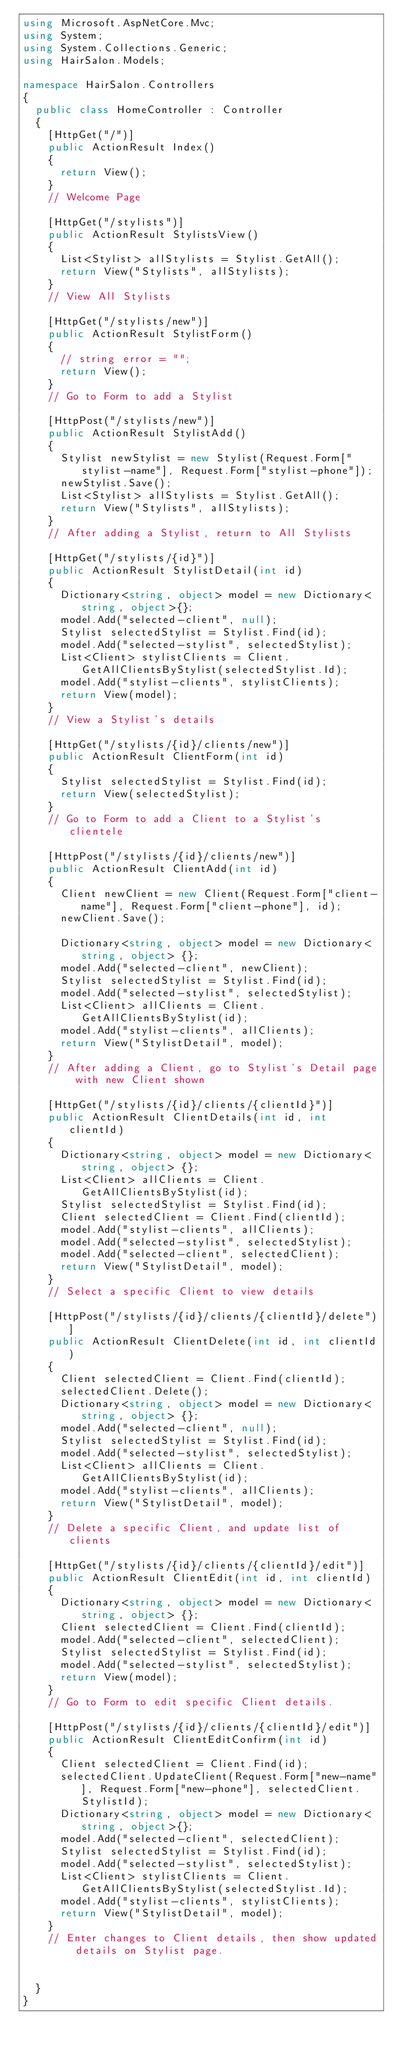Convert code to text. <code><loc_0><loc_0><loc_500><loc_500><_C#_>using Microsoft.AspNetCore.Mvc;
using System;
using System.Collections.Generic;
using HairSalon.Models;

namespace HairSalon.Controllers
{
  public class HomeController : Controller
  {
    [HttpGet("/")]
    public ActionResult Index()
    {
      return View();
    }
    // Welcome Page

    [HttpGet("/stylists")]
    public ActionResult StylistsView()
    {
      List<Stylist> allStylists = Stylist.GetAll();
      return View("Stylists", allStylists);
    }
    // View All Stylists

    [HttpGet("/stylists/new")]
    public ActionResult StylistForm()
    {
      // string error = "";
      return View();
    }
    // Go to Form to add a Stylist

    [HttpPost("/stylists/new")]
    public ActionResult StylistAdd()
    {
      Stylist newStylist = new Stylist(Request.Form["stylist-name"], Request.Form["stylist-phone"]);
      newStylist.Save();
      List<Stylist> allStylists = Stylist.GetAll();
      return View("Stylists", allStylists);
    }
    // After adding a Stylist, return to All Stylists

    [HttpGet("/stylists/{id}")]
    public ActionResult StylistDetail(int id)
    {
      Dictionary<string, object> model = new Dictionary<string, object>{};
      model.Add("selected-client", null);
      Stylist selectedStylist = Stylist.Find(id);
      model.Add("selected-stylist", selectedStylist);
      List<Client> stylistClients = Client.GetAllClientsByStylist(selectedStylist.Id);
      model.Add("stylist-clients", stylistClients);
      return View(model);
    }
    // View a Stylist's details

    [HttpGet("/stylists/{id}/clients/new")]
    public ActionResult ClientForm(int id)
    {
      Stylist selectedStylist = Stylist.Find(id);
      return View(selectedStylist);
    }
    // Go to Form to add a Client to a Stylist's clientele

    [HttpPost("/stylists/{id}/clients/new")]
    public ActionResult ClientAdd(int id)
    {
      Client newClient = new Client(Request.Form["client-name"], Request.Form["client-phone"], id);
      newClient.Save();

      Dictionary<string, object> model = new Dictionary<string, object> {};
      model.Add("selected-client", newClient);
      Stylist selectedStylist = Stylist.Find(id);
      model.Add("selected-stylist", selectedStylist);
      List<Client> allClients = Client.GetAllClientsByStylist(id);
      model.Add("stylist-clients", allClients);
      return View("StylistDetail", model);
    }
    // After adding a Client, go to Stylist's Detail page with new Client shown

    [HttpGet("/stylists/{id}/clients/{clientId}")]
    public ActionResult ClientDetails(int id, int clientId)
    {
      Dictionary<string, object> model = new Dictionary<string, object> {};
      List<Client> allClients = Client.GetAllClientsByStylist(id);
      Stylist selectedStylist = Stylist.Find(id);
      Client selectedClient = Client.Find(clientId);
      model.Add("stylist-clients", allClients);
      model.Add("selected-stylist", selectedStylist);
      model.Add("selected-client", selectedClient);
      return View("StylistDetail", model);
    }
    // Select a specific Client to view details

    [HttpPost("/stylists/{id}/clients/{clientId}/delete")]
    public ActionResult ClientDelete(int id, int clientId)
    {
      Client selectedClient = Client.Find(clientId);
      selectedClient.Delete();
      Dictionary<string, object> model = new Dictionary<string, object> {};
      model.Add("selected-client", null);
      Stylist selectedStylist = Stylist.Find(id);
      model.Add("selected-stylist", selectedStylist);
      List<Client> allClients = Client.GetAllClientsByStylist(id);
      model.Add("stylist-clients", allClients);
      return View("StylistDetail", model);
    }
    // Delete a specific Client, and update list of clients

    [HttpGet("/stylists/{id}/clients/{clientId}/edit")]
    public ActionResult ClientEdit(int id, int clientId)
    {
      Dictionary<string, object> model = new Dictionary<string, object> {};
      Client selectedClient = Client.Find(clientId);
      model.Add("selected-client", selectedClient);
      Stylist selectedStylist = Stylist.Find(id);
      model.Add("selected-stylist", selectedStylist);
      return View(model);
    }
    // Go to Form to edit specific Client details.

    [HttpPost("/stylists/{id}/clients/{clientId}/edit")]
    public ActionResult ClientEditConfirm(int id)
    {
      Client selectedClient = Client.Find(id);
      selectedClient.UpdateClient(Request.Form["new-name"], Request.Form["new-phone"], selectedClient.StylistId);
      Dictionary<string, object> model = new Dictionary<string, object>{};
      model.Add("selected-client", selectedClient);
      Stylist selectedStylist = Stylist.Find(id);
      model.Add("selected-stylist", selectedStylist);
      List<Client> stylistClients = Client.GetAllClientsByStylist(selectedStylist.Id);
      model.Add("stylist-clients", stylistClients);
      return View("StylistDetail", model);
    }
    // Enter changes to Client details, then show updated details on Stylist page.


  }
}
</code> 